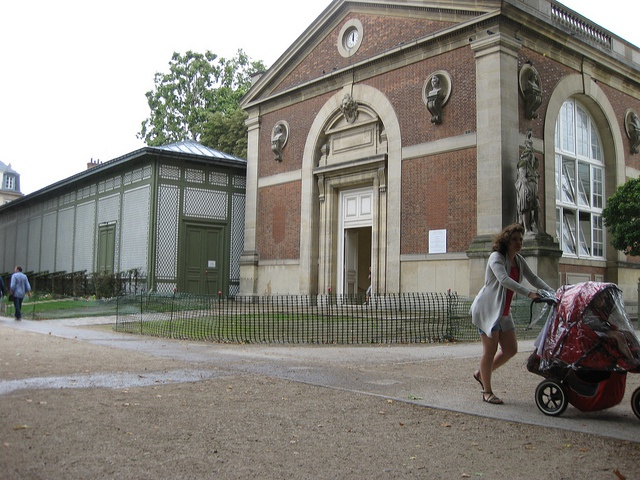Describe the objects in this image and their specific colors. I can see people in white, black, gray, darkgray, and maroon tones, people in white, black, and gray tones, people in white, black, gray, and navy tones, clock in white, lightgray, darkgray, and gray tones, and people in white, black, gray, and darkgray tones in this image. 